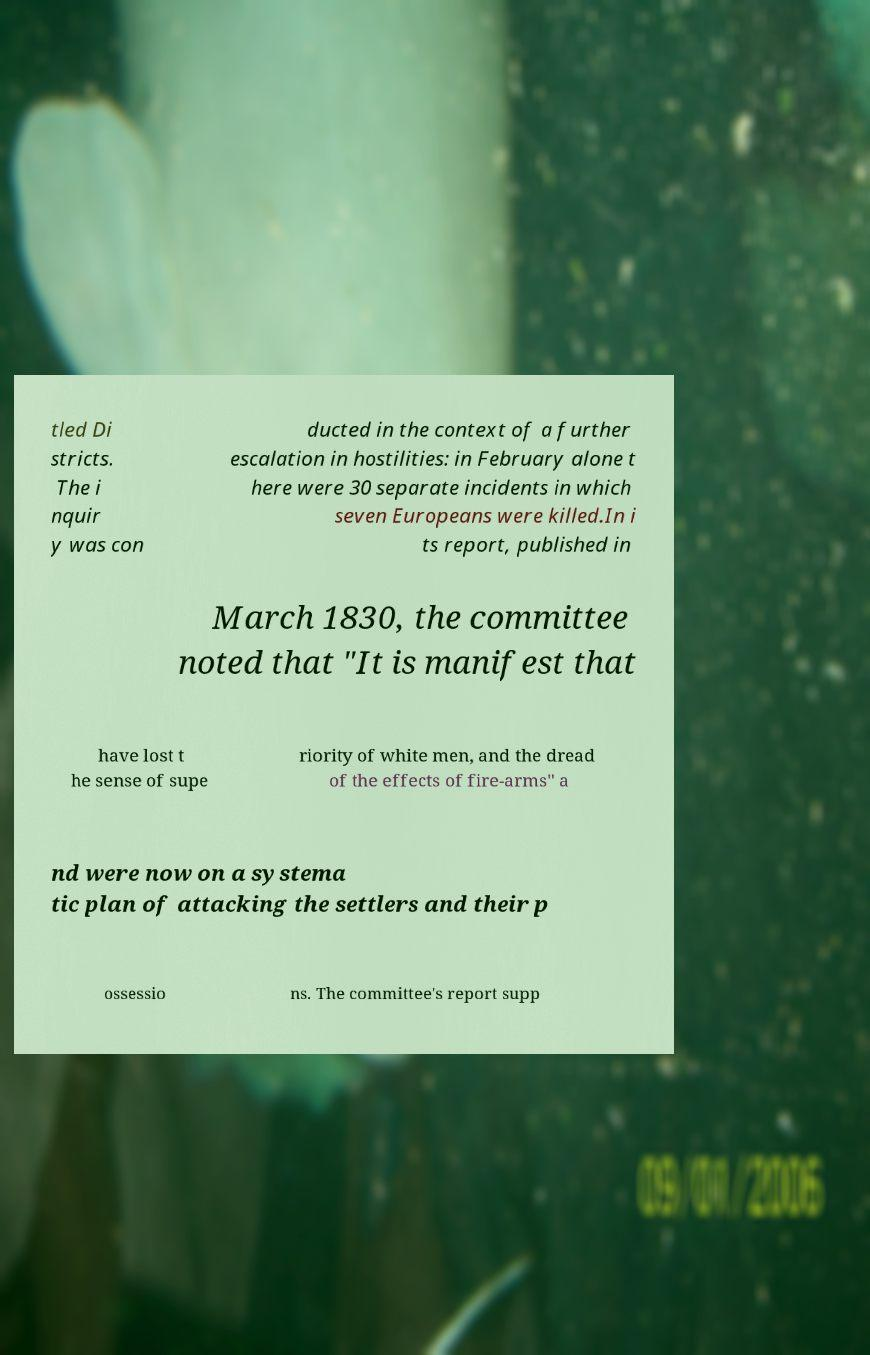Can you accurately transcribe the text from the provided image for me? tled Di stricts. The i nquir y was con ducted in the context of a further escalation in hostilities: in February alone t here were 30 separate incidents in which seven Europeans were killed.In i ts report, published in March 1830, the committee noted that "It is manifest that have lost t he sense of supe riority of white men, and the dread of the effects of fire-arms" a nd were now on a systema tic plan of attacking the settlers and their p ossessio ns. The committee's report supp 